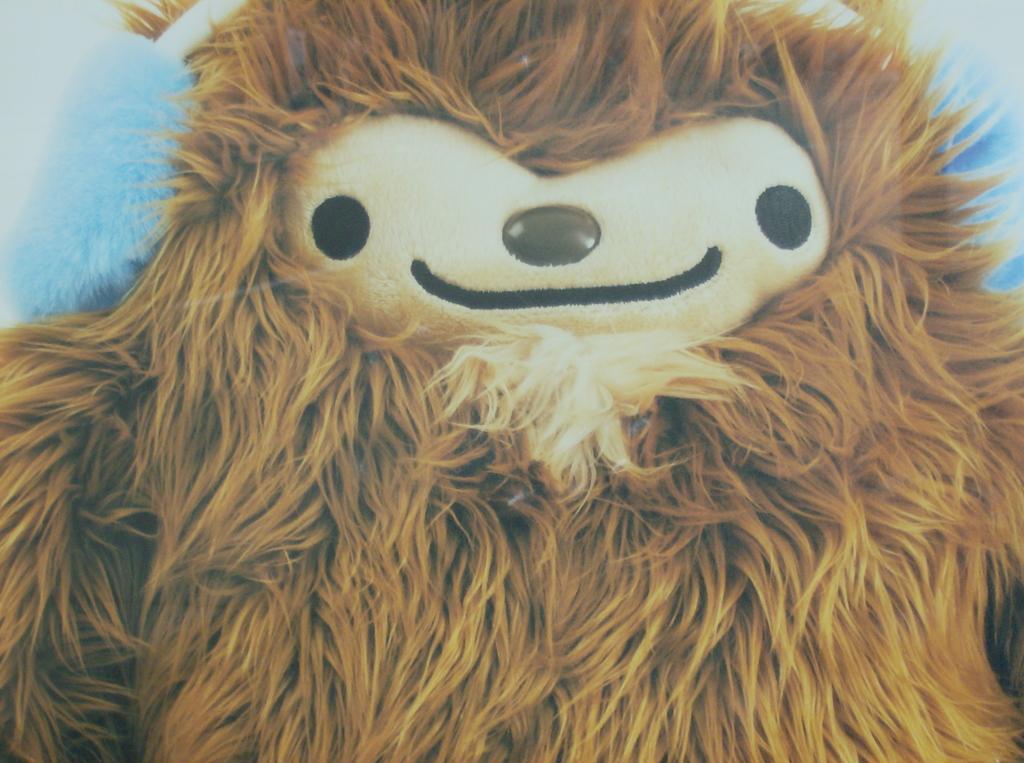In one or two sentences, can you explain what this image depicts? In this image we can see a soft toy. 